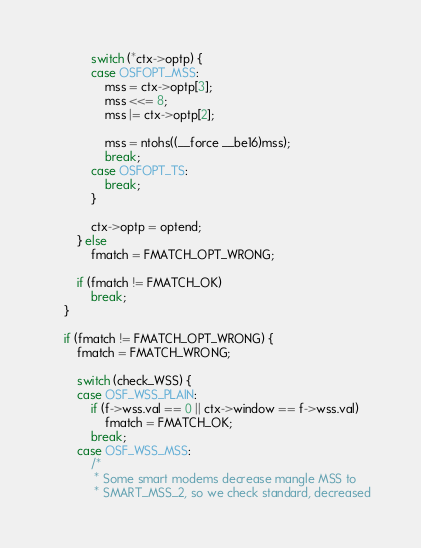<code> <loc_0><loc_0><loc_500><loc_500><_C_>
			switch (*ctx->optp) {
			case OSFOPT_MSS:
				mss = ctx->optp[3];
				mss <<= 8;
				mss |= ctx->optp[2];

				mss = ntohs((__force __be16)mss);
				break;
			case OSFOPT_TS:
				break;
			}

			ctx->optp = optend;
		} else
			fmatch = FMATCH_OPT_WRONG;

		if (fmatch != FMATCH_OK)
			break;
	}

	if (fmatch != FMATCH_OPT_WRONG) {
		fmatch = FMATCH_WRONG;

		switch (check_WSS) {
		case OSF_WSS_PLAIN:
			if (f->wss.val == 0 || ctx->window == f->wss.val)
				fmatch = FMATCH_OK;
			break;
		case OSF_WSS_MSS:
			/*
			 * Some smart modems decrease mangle MSS to
			 * SMART_MSS_2, so we check standard, decreased</code> 